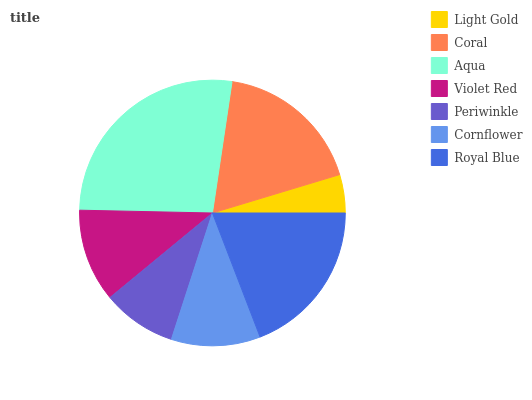Is Light Gold the minimum?
Answer yes or no. Yes. Is Aqua the maximum?
Answer yes or no. Yes. Is Coral the minimum?
Answer yes or no. No. Is Coral the maximum?
Answer yes or no. No. Is Coral greater than Light Gold?
Answer yes or no. Yes. Is Light Gold less than Coral?
Answer yes or no. Yes. Is Light Gold greater than Coral?
Answer yes or no. No. Is Coral less than Light Gold?
Answer yes or no. No. Is Violet Red the high median?
Answer yes or no. Yes. Is Violet Red the low median?
Answer yes or no. Yes. Is Periwinkle the high median?
Answer yes or no. No. Is Light Gold the low median?
Answer yes or no. No. 